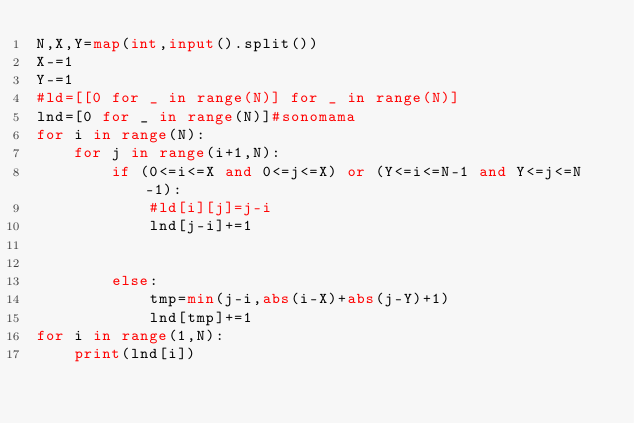<code> <loc_0><loc_0><loc_500><loc_500><_Python_>N,X,Y=map(int,input().split())
X-=1
Y-=1
#ld=[[0 for _ in range(N)] for _ in range(N)]
lnd=[0 for _ in range(N)]#sonomama
for i in range(N):
    for j in range(i+1,N):
        if (0<=i<=X and 0<=j<=X) or (Y<=i<=N-1 and Y<=j<=N-1):
            #ld[i][j]=j-i
            lnd[j-i]+=1

     
        else:
            tmp=min(j-i,abs(i-X)+abs(j-Y)+1)
            lnd[tmp]+=1
for i in range(1,N):
    print(lnd[i])
</code> 